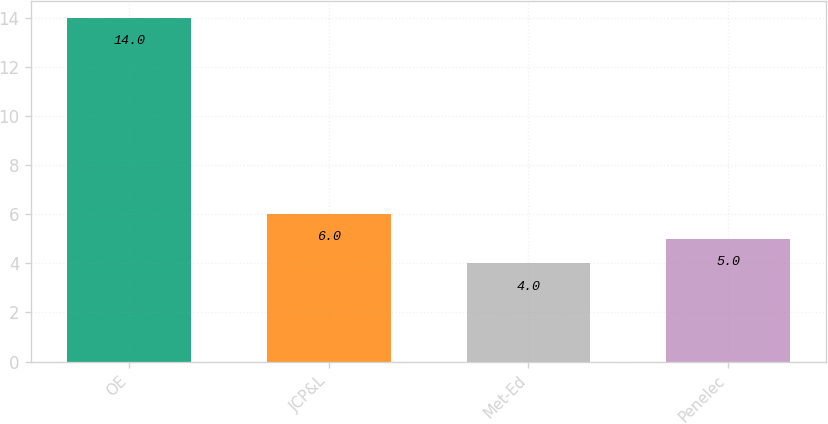Convert chart. <chart><loc_0><loc_0><loc_500><loc_500><bar_chart><fcel>OE<fcel>JCP&L<fcel>Met-Ed<fcel>Penelec<nl><fcel>14<fcel>6<fcel>4<fcel>5<nl></chart> 